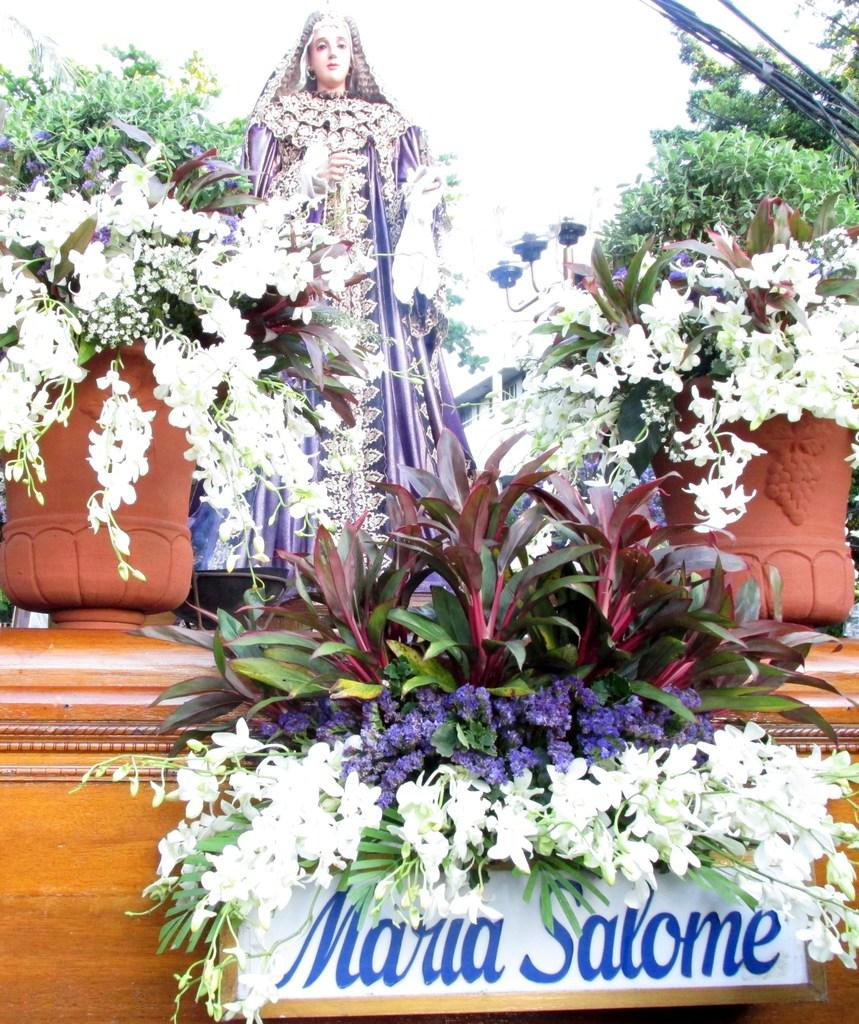What type of flora is present in the image? There are flowers in the image. What type of artwork can be seen in the image? There is a sculpture in the image. What type of vegetation is visible in the image? There are trees in the image. What type of jewelry is hanging from the tree in the image? There is no jewelry present in the image. What type of wind can be seen blowing through the image? There is no wind present in the image. What type of celestial body is visible in the image? There is no celestial body visible in the image. 